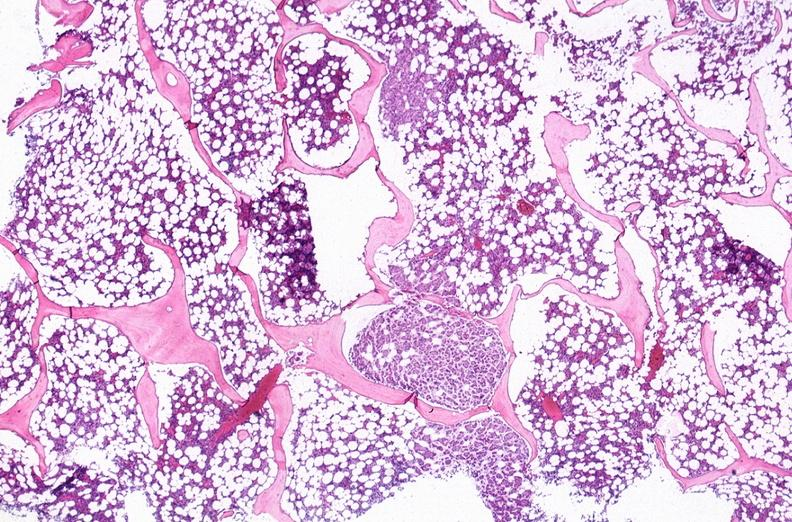does blood show breast cancer metastasis to bone marrow?
Answer the question using a single word or phrase. No 